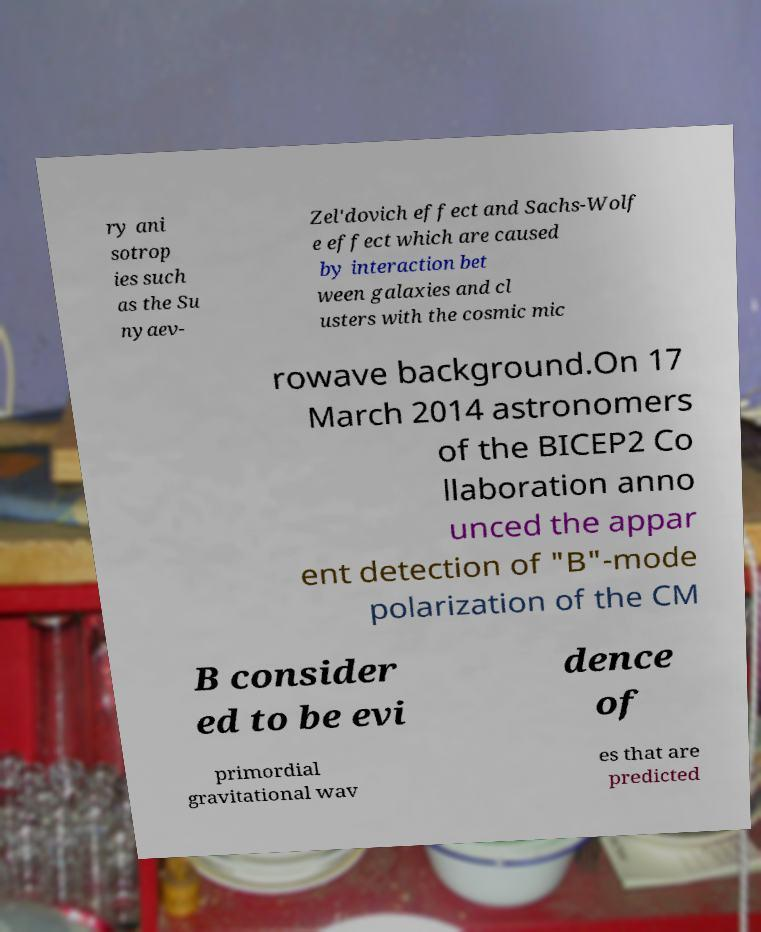Could you assist in decoding the text presented in this image and type it out clearly? ry ani sotrop ies such as the Su nyaev- Zel'dovich effect and Sachs-Wolf e effect which are caused by interaction bet ween galaxies and cl usters with the cosmic mic rowave background.On 17 March 2014 astronomers of the BICEP2 Co llaboration anno unced the appar ent detection of "B"-mode polarization of the CM B consider ed to be evi dence of primordial gravitational wav es that are predicted 